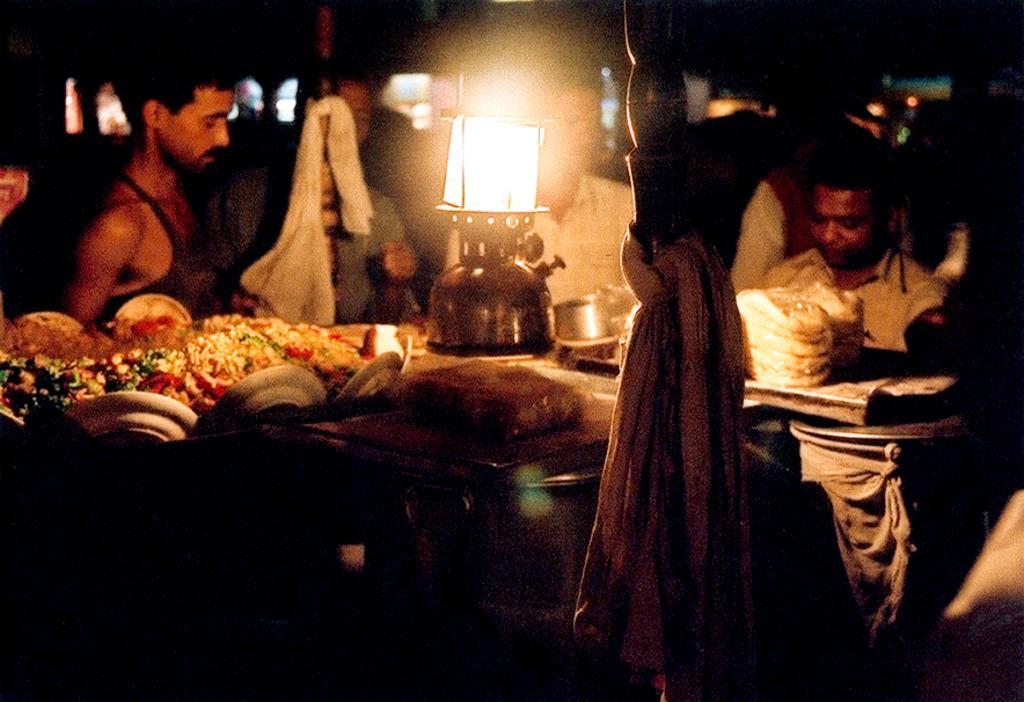Could you give a brief overview of what you see in this image? In this image I can see four persons are standing on the floor in front of a table on which I can see plates, food items and so on. In the background I can see a wall and lights. This image is taken may be in a room. 